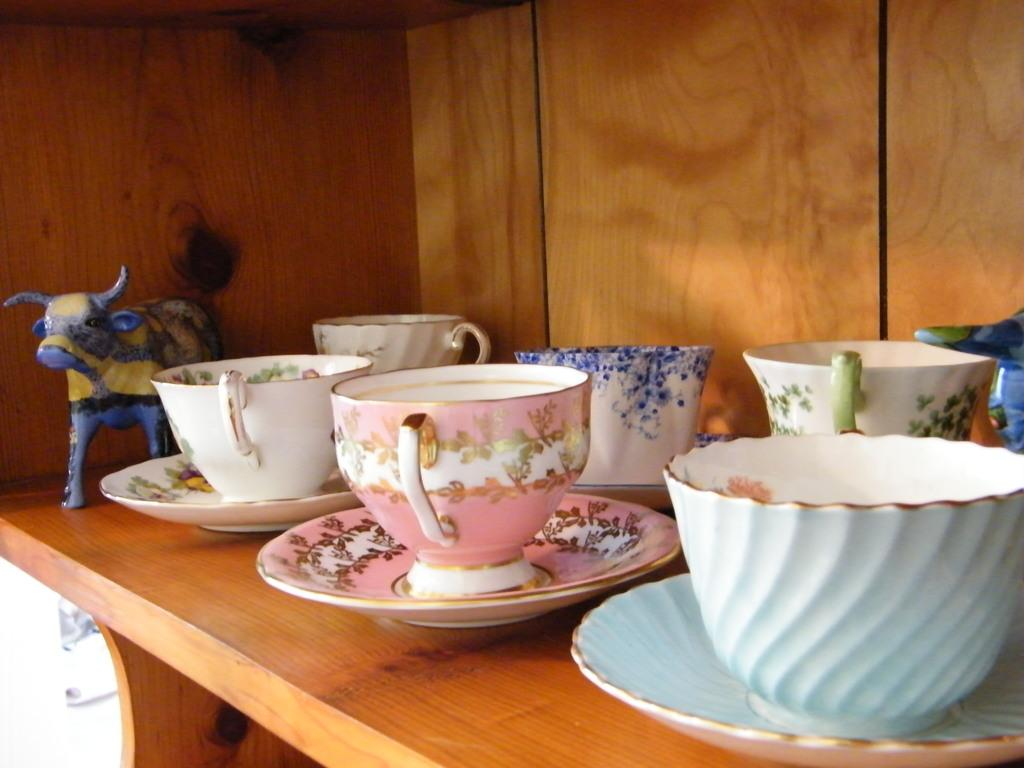What type of dishware can be seen in the image? There are coffee cups and saucers in the image. Where are the coffee cups and saucers located? They are on a wooden plank. Are there any other objects present in the image? Yes, there is a ceramic buffalo in the image. How many geese are flying over the hill in the image? There are no geese or hills present in the image. Is there a maid serving coffee in the image? There is no maid or indication of anyone serving coffee in the image. 